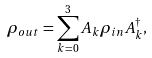Convert formula to latex. <formula><loc_0><loc_0><loc_500><loc_500>\rho _ { o u t } = \sum _ { k = 0 } ^ { 3 } { A _ { k } \rho _ { i n } A _ { k } ^ { \dag } } ,</formula> 